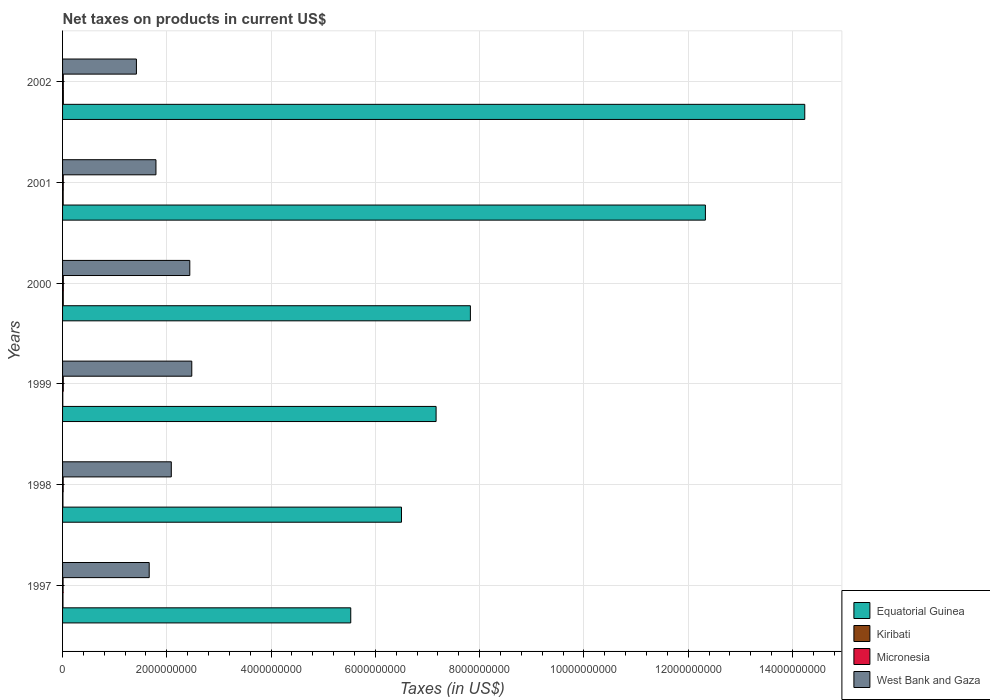How many different coloured bars are there?
Keep it short and to the point. 4. How many groups of bars are there?
Provide a short and direct response. 6. Are the number of bars per tick equal to the number of legend labels?
Your answer should be very brief. Yes. Are the number of bars on each tick of the Y-axis equal?
Give a very brief answer. Yes. How many bars are there on the 5th tick from the top?
Make the answer very short. 4. How many bars are there on the 1st tick from the bottom?
Provide a short and direct response. 4. In how many cases, is the number of bars for a given year not equal to the number of legend labels?
Provide a succinct answer. 0. What is the net taxes on products in Equatorial Guinea in 2000?
Offer a terse response. 7.82e+09. Across all years, what is the maximum net taxes on products in Kiribati?
Your answer should be very brief. 1.52e+07. Across all years, what is the minimum net taxes on products in Kiribati?
Keep it short and to the point. 4.38e+06. What is the total net taxes on products in Kiribati in the graph?
Provide a succinct answer. 6.04e+07. What is the difference between the net taxes on products in Equatorial Guinea in 1999 and that in 2000?
Give a very brief answer. -6.58e+08. What is the difference between the net taxes on products in Kiribati in 2000 and the net taxes on products in Micronesia in 2002?
Offer a very short reply. -7.20e+05. What is the average net taxes on products in Equatorial Guinea per year?
Offer a terse response. 8.93e+09. In the year 1999, what is the difference between the net taxes on products in West Bank and Gaza and net taxes on products in Kiribati?
Provide a short and direct response. 2.47e+09. In how many years, is the net taxes on products in Kiribati greater than 6400000000 US$?
Your response must be concise. 0. What is the ratio of the net taxes on products in Kiribati in 1997 to that in 1999?
Your answer should be very brief. 1.85. What is the difference between the highest and the second highest net taxes on products in Micronesia?
Keep it short and to the point. 4.29e+05. What is the difference between the highest and the lowest net taxes on products in Micronesia?
Provide a short and direct response. 4.64e+06. Is the sum of the net taxes on products in Micronesia in 1998 and 2000 greater than the maximum net taxes on products in West Bank and Gaza across all years?
Offer a terse response. No. Is it the case that in every year, the sum of the net taxes on products in Micronesia and net taxes on products in West Bank and Gaza is greater than the sum of net taxes on products in Equatorial Guinea and net taxes on products in Kiribati?
Make the answer very short. Yes. What does the 4th bar from the top in 1997 represents?
Offer a terse response. Equatorial Guinea. What does the 1st bar from the bottom in 1998 represents?
Provide a succinct answer. Equatorial Guinea. How many bars are there?
Give a very brief answer. 24. Are all the bars in the graph horizontal?
Your response must be concise. Yes. How many years are there in the graph?
Your response must be concise. 6. Does the graph contain any zero values?
Provide a short and direct response. No. How many legend labels are there?
Give a very brief answer. 4. What is the title of the graph?
Offer a very short reply. Net taxes on products in current US$. What is the label or title of the X-axis?
Your answer should be very brief. Taxes (in US$). What is the Taxes (in US$) of Equatorial Guinea in 1997?
Offer a terse response. 5.53e+09. What is the Taxes (in US$) of Kiribati in 1997?
Offer a terse response. 8.11e+06. What is the Taxes (in US$) in Micronesia in 1997?
Provide a short and direct response. 1.00e+07. What is the Taxes (in US$) of West Bank and Gaza in 1997?
Ensure brevity in your answer.  1.66e+09. What is the Taxes (in US$) in Equatorial Guinea in 1998?
Ensure brevity in your answer.  6.50e+09. What is the Taxes (in US$) of Kiribati in 1998?
Your response must be concise. 7.34e+06. What is the Taxes (in US$) in Micronesia in 1998?
Provide a short and direct response. 1.18e+07. What is the Taxes (in US$) in West Bank and Gaza in 1998?
Offer a terse response. 2.09e+09. What is the Taxes (in US$) in Equatorial Guinea in 1999?
Your response must be concise. 7.16e+09. What is the Taxes (in US$) in Kiribati in 1999?
Give a very brief answer. 4.38e+06. What is the Taxes (in US$) of Micronesia in 1999?
Your response must be concise. 1.37e+07. What is the Taxes (in US$) of West Bank and Gaza in 1999?
Your answer should be compact. 2.48e+09. What is the Taxes (in US$) of Equatorial Guinea in 2000?
Ensure brevity in your answer.  7.82e+09. What is the Taxes (in US$) of Kiribati in 2000?
Offer a very short reply. 1.35e+07. What is the Taxes (in US$) in Micronesia in 2000?
Your response must be concise. 1.47e+07. What is the Taxes (in US$) of West Bank and Gaza in 2000?
Provide a succinct answer. 2.44e+09. What is the Taxes (in US$) of Equatorial Guinea in 2001?
Make the answer very short. 1.23e+1. What is the Taxes (in US$) in Kiribati in 2001?
Give a very brief answer. 1.18e+07. What is the Taxes (in US$) of Micronesia in 2001?
Your answer should be compact. 1.35e+07. What is the Taxes (in US$) of West Bank and Gaza in 2001?
Keep it short and to the point. 1.79e+09. What is the Taxes (in US$) of Equatorial Guinea in 2002?
Your answer should be very brief. 1.42e+1. What is the Taxes (in US$) of Kiribati in 2002?
Ensure brevity in your answer.  1.52e+07. What is the Taxes (in US$) of Micronesia in 2002?
Your response must be concise. 1.42e+07. What is the Taxes (in US$) in West Bank and Gaza in 2002?
Provide a succinct answer. 1.42e+09. Across all years, what is the maximum Taxes (in US$) in Equatorial Guinea?
Provide a short and direct response. 1.42e+1. Across all years, what is the maximum Taxes (in US$) in Kiribati?
Make the answer very short. 1.52e+07. Across all years, what is the maximum Taxes (in US$) in Micronesia?
Give a very brief answer. 1.47e+07. Across all years, what is the maximum Taxes (in US$) in West Bank and Gaza?
Your response must be concise. 2.48e+09. Across all years, what is the minimum Taxes (in US$) of Equatorial Guinea?
Keep it short and to the point. 5.53e+09. Across all years, what is the minimum Taxes (in US$) of Kiribati?
Your response must be concise. 4.38e+06. Across all years, what is the minimum Taxes (in US$) in Micronesia?
Offer a terse response. 1.00e+07. Across all years, what is the minimum Taxes (in US$) of West Bank and Gaza?
Make the answer very short. 1.42e+09. What is the total Taxes (in US$) of Equatorial Guinea in the graph?
Your answer should be compact. 5.36e+1. What is the total Taxes (in US$) of Kiribati in the graph?
Offer a very short reply. 6.04e+07. What is the total Taxes (in US$) in Micronesia in the graph?
Your answer should be compact. 7.79e+07. What is the total Taxes (in US$) in West Bank and Gaza in the graph?
Give a very brief answer. 1.19e+1. What is the difference between the Taxes (in US$) in Equatorial Guinea in 1997 and that in 1998?
Your answer should be very brief. -9.73e+08. What is the difference between the Taxes (in US$) of Kiribati in 1997 and that in 1998?
Your response must be concise. 7.73e+05. What is the difference between the Taxes (in US$) in Micronesia in 1997 and that in 1998?
Provide a succinct answer. -1.83e+06. What is the difference between the Taxes (in US$) in West Bank and Gaza in 1997 and that in 1998?
Your answer should be compact. -4.24e+08. What is the difference between the Taxes (in US$) in Equatorial Guinea in 1997 and that in 1999?
Give a very brief answer. -1.64e+09. What is the difference between the Taxes (in US$) of Kiribati in 1997 and that in 1999?
Provide a short and direct response. 3.73e+06. What is the difference between the Taxes (in US$) in Micronesia in 1997 and that in 1999?
Your response must be concise. -3.65e+06. What is the difference between the Taxes (in US$) in West Bank and Gaza in 1997 and that in 1999?
Offer a terse response. -8.17e+08. What is the difference between the Taxes (in US$) in Equatorial Guinea in 1997 and that in 2000?
Make the answer very short. -2.30e+09. What is the difference between the Taxes (in US$) of Kiribati in 1997 and that in 2000?
Offer a very short reply. -5.40e+06. What is the difference between the Taxes (in US$) of Micronesia in 1997 and that in 2000?
Offer a terse response. -4.64e+06. What is the difference between the Taxes (in US$) in West Bank and Gaza in 1997 and that in 2000?
Offer a terse response. -7.79e+08. What is the difference between the Taxes (in US$) of Equatorial Guinea in 1997 and that in 2001?
Give a very brief answer. -6.80e+09. What is the difference between the Taxes (in US$) in Kiribati in 1997 and that in 2001?
Your response must be concise. -3.70e+06. What is the difference between the Taxes (in US$) of Micronesia in 1997 and that in 2001?
Keep it short and to the point. -3.47e+06. What is the difference between the Taxes (in US$) in West Bank and Gaza in 1997 and that in 2001?
Your answer should be compact. -1.29e+08. What is the difference between the Taxes (in US$) of Equatorial Guinea in 1997 and that in 2002?
Ensure brevity in your answer.  -8.71e+09. What is the difference between the Taxes (in US$) of Kiribati in 1997 and that in 2002?
Offer a very short reply. -7.10e+06. What is the difference between the Taxes (in US$) of Micronesia in 1997 and that in 2002?
Give a very brief answer. -4.21e+06. What is the difference between the Taxes (in US$) in West Bank and Gaza in 1997 and that in 2002?
Offer a terse response. 2.45e+08. What is the difference between the Taxes (in US$) in Equatorial Guinea in 1998 and that in 1999?
Your answer should be very brief. -6.64e+08. What is the difference between the Taxes (in US$) of Kiribati in 1998 and that in 1999?
Keep it short and to the point. 2.95e+06. What is the difference between the Taxes (in US$) in Micronesia in 1998 and that in 1999?
Offer a very short reply. -1.82e+06. What is the difference between the Taxes (in US$) in West Bank and Gaza in 1998 and that in 1999?
Offer a terse response. -3.93e+08. What is the difference between the Taxes (in US$) in Equatorial Guinea in 1998 and that in 2000?
Give a very brief answer. -1.32e+09. What is the difference between the Taxes (in US$) of Kiribati in 1998 and that in 2000?
Give a very brief answer. -6.17e+06. What is the difference between the Taxes (in US$) of Micronesia in 1998 and that in 2000?
Offer a terse response. -2.81e+06. What is the difference between the Taxes (in US$) in West Bank and Gaza in 1998 and that in 2000?
Keep it short and to the point. -3.55e+08. What is the difference between the Taxes (in US$) of Equatorial Guinea in 1998 and that in 2001?
Keep it short and to the point. -5.83e+09. What is the difference between the Taxes (in US$) of Kiribati in 1998 and that in 2001?
Your answer should be compact. -4.47e+06. What is the difference between the Taxes (in US$) in Micronesia in 1998 and that in 2001?
Make the answer very short. -1.64e+06. What is the difference between the Taxes (in US$) in West Bank and Gaza in 1998 and that in 2001?
Ensure brevity in your answer.  2.94e+08. What is the difference between the Taxes (in US$) in Equatorial Guinea in 1998 and that in 2002?
Keep it short and to the point. -7.74e+09. What is the difference between the Taxes (in US$) in Kiribati in 1998 and that in 2002?
Offer a terse response. -7.88e+06. What is the difference between the Taxes (in US$) in Micronesia in 1998 and that in 2002?
Give a very brief answer. -2.38e+06. What is the difference between the Taxes (in US$) of West Bank and Gaza in 1998 and that in 2002?
Give a very brief answer. 6.69e+08. What is the difference between the Taxes (in US$) of Equatorial Guinea in 1999 and that in 2000?
Offer a very short reply. -6.58e+08. What is the difference between the Taxes (in US$) in Kiribati in 1999 and that in 2000?
Your answer should be very brief. -9.12e+06. What is the difference between the Taxes (in US$) of Micronesia in 1999 and that in 2000?
Provide a succinct answer. -9.94e+05. What is the difference between the Taxes (in US$) of West Bank and Gaza in 1999 and that in 2000?
Your response must be concise. 3.80e+07. What is the difference between the Taxes (in US$) of Equatorial Guinea in 1999 and that in 2001?
Make the answer very short. -5.17e+09. What is the difference between the Taxes (in US$) of Kiribati in 1999 and that in 2001?
Provide a short and direct response. -7.42e+06. What is the difference between the Taxes (in US$) of Micronesia in 1999 and that in 2001?
Provide a short and direct response. 1.83e+05. What is the difference between the Taxes (in US$) of West Bank and Gaza in 1999 and that in 2001?
Ensure brevity in your answer.  6.87e+08. What is the difference between the Taxes (in US$) of Equatorial Guinea in 1999 and that in 2002?
Make the answer very short. -7.07e+09. What is the difference between the Taxes (in US$) of Kiribati in 1999 and that in 2002?
Ensure brevity in your answer.  -1.08e+07. What is the difference between the Taxes (in US$) in Micronesia in 1999 and that in 2002?
Keep it short and to the point. -5.65e+05. What is the difference between the Taxes (in US$) in West Bank and Gaza in 1999 and that in 2002?
Ensure brevity in your answer.  1.06e+09. What is the difference between the Taxes (in US$) of Equatorial Guinea in 2000 and that in 2001?
Make the answer very short. -4.51e+09. What is the difference between the Taxes (in US$) of Kiribati in 2000 and that in 2001?
Provide a short and direct response. 1.70e+06. What is the difference between the Taxes (in US$) in Micronesia in 2000 and that in 2001?
Make the answer very short. 1.18e+06. What is the difference between the Taxes (in US$) in West Bank and Gaza in 2000 and that in 2001?
Give a very brief answer. 6.49e+08. What is the difference between the Taxes (in US$) in Equatorial Guinea in 2000 and that in 2002?
Make the answer very short. -6.41e+09. What is the difference between the Taxes (in US$) in Kiribati in 2000 and that in 2002?
Provide a succinct answer. -1.70e+06. What is the difference between the Taxes (in US$) of Micronesia in 2000 and that in 2002?
Give a very brief answer. 4.29e+05. What is the difference between the Taxes (in US$) of West Bank and Gaza in 2000 and that in 2002?
Keep it short and to the point. 1.02e+09. What is the difference between the Taxes (in US$) in Equatorial Guinea in 2001 and that in 2002?
Keep it short and to the point. -1.91e+09. What is the difference between the Taxes (in US$) in Kiribati in 2001 and that in 2002?
Provide a succinct answer. -3.41e+06. What is the difference between the Taxes (in US$) of Micronesia in 2001 and that in 2002?
Ensure brevity in your answer.  -7.48e+05. What is the difference between the Taxes (in US$) of West Bank and Gaza in 2001 and that in 2002?
Your answer should be very brief. 3.75e+08. What is the difference between the Taxes (in US$) in Equatorial Guinea in 1997 and the Taxes (in US$) in Kiribati in 1998?
Your answer should be compact. 5.52e+09. What is the difference between the Taxes (in US$) in Equatorial Guinea in 1997 and the Taxes (in US$) in Micronesia in 1998?
Keep it short and to the point. 5.52e+09. What is the difference between the Taxes (in US$) in Equatorial Guinea in 1997 and the Taxes (in US$) in West Bank and Gaza in 1998?
Provide a short and direct response. 3.44e+09. What is the difference between the Taxes (in US$) of Kiribati in 1997 and the Taxes (in US$) of Micronesia in 1998?
Your answer should be compact. -3.73e+06. What is the difference between the Taxes (in US$) of Kiribati in 1997 and the Taxes (in US$) of West Bank and Gaza in 1998?
Give a very brief answer. -2.08e+09. What is the difference between the Taxes (in US$) in Micronesia in 1997 and the Taxes (in US$) in West Bank and Gaza in 1998?
Ensure brevity in your answer.  -2.08e+09. What is the difference between the Taxes (in US$) in Equatorial Guinea in 1997 and the Taxes (in US$) in Kiribati in 1999?
Make the answer very short. 5.52e+09. What is the difference between the Taxes (in US$) in Equatorial Guinea in 1997 and the Taxes (in US$) in Micronesia in 1999?
Make the answer very short. 5.51e+09. What is the difference between the Taxes (in US$) of Equatorial Guinea in 1997 and the Taxes (in US$) of West Bank and Gaza in 1999?
Give a very brief answer. 3.05e+09. What is the difference between the Taxes (in US$) of Kiribati in 1997 and the Taxes (in US$) of Micronesia in 1999?
Offer a very short reply. -5.55e+06. What is the difference between the Taxes (in US$) in Kiribati in 1997 and the Taxes (in US$) in West Bank and Gaza in 1999?
Give a very brief answer. -2.47e+09. What is the difference between the Taxes (in US$) in Micronesia in 1997 and the Taxes (in US$) in West Bank and Gaza in 1999?
Your answer should be very brief. -2.47e+09. What is the difference between the Taxes (in US$) in Equatorial Guinea in 1997 and the Taxes (in US$) in Kiribati in 2000?
Give a very brief answer. 5.51e+09. What is the difference between the Taxes (in US$) in Equatorial Guinea in 1997 and the Taxes (in US$) in Micronesia in 2000?
Your answer should be very brief. 5.51e+09. What is the difference between the Taxes (in US$) of Equatorial Guinea in 1997 and the Taxes (in US$) of West Bank and Gaza in 2000?
Ensure brevity in your answer.  3.09e+09. What is the difference between the Taxes (in US$) of Kiribati in 1997 and the Taxes (in US$) of Micronesia in 2000?
Your response must be concise. -6.55e+06. What is the difference between the Taxes (in US$) in Kiribati in 1997 and the Taxes (in US$) in West Bank and Gaza in 2000?
Provide a short and direct response. -2.43e+09. What is the difference between the Taxes (in US$) of Micronesia in 1997 and the Taxes (in US$) of West Bank and Gaza in 2000?
Your response must be concise. -2.43e+09. What is the difference between the Taxes (in US$) in Equatorial Guinea in 1997 and the Taxes (in US$) in Kiribati in 2001?
Provide a succinct answer. 5.52e+09. What is the difference between the Taxes (in US$) of Equatorial Guinea in 1997 and the Taxes (in US$) of Micronesia in 2001?
Provide a succinct answer. 5.51e+09. What is the difference between the Taxes (in US$) of Equatorial Guinea in 1997 and the Taxes (in US$) of West Bank and Gaza in 2001?
Offer a terse response. 3.74e+09. What is the difference between the Taxes (in US$) in Kiribati in 1997 and the Taxes (in US$) in Micronesia in 2001?
Ensure brevity in your answer.  -5.37e+06. What is the difference between the Taxes (in US$) of Kiribati in 1997 and the Taxes (in US$) of West Bank and Gaza in 2001?
Make the answer very short. -1.78e+09. What is the difference between the Taxes (in US$) of Micronesia in 1997 and the Taxes (in US$) of West Bank and Gaza in 2001?
Ensure brevity in your answer.  -1.78e+09. What is the difference between the Taxes (in US$) in Equatorial Guinea in 1997 and the Taxes (in US$) in Kiribati in 2002?
Ensure brevity in your answer.  5.51e+09. What is the difference between the Taxes (in US$) of Equatorial Guinea in 1997 and the Taxes (in US$) of Micronesia in 2002?
Offer a very short reply. 5.51e+09. What is the difference between the Taxes (in US$) of Equatorial Guinea in 1997 and the Taxes (in US$) of West Bank and Gaza in 2002?
Keep it short and to the point. 4.11e+09. What is the difference between the Taxes (in US$) in Kiribati in 1997 and the Taxes (in US$) in Micronesia in 2002?
Your answer should be compact. -6.12e+06. What is the difference between the Taxes (in US$) of Kiribati in 1997 and the Taxes (in US$) of West Bank and Gaza in 2002?
Ensure brevity in your answer.  -1.41e+09. What is the difference between the Taxes (in US$) of Micronesia in 1997 and the Taxes (in US$) of West Bank and Gaza in 2002?
Offer a very short reply. -1.41e+09. What is the difference between the Taxes (in US$) of Equatorial Guinea in 1998 and the Taxes (in US$) of Kiribati in 1999?
Provide a succinct answer. 6.50e+09. What is the difference between the Taxes (in US$) in Equatorial Guinea in 1998 and the Taxes (in US$) in Micronesia in 1999?
Keep it short and to the point. 6.49e+09. What is the difference between the Taxes (in US$) of Equatorial Guinea in 1998 and the Taxes (in US$) of West Bank and Gaza in 1999?
Offer a terse response. 4.02e+09. What is the difference between the Taxes (in US$) of Kiribati in 1998 and the Taxes (in US$) of Micronesia in 1999?
Offer a very short reply. -6.32e+06. What is the difference between the Taxes (in US$) in Kiribati in 1998 and the Taxes (in US$) in West Bank and Gaza in 1999?
Provide a short and direct response. -2.47e+09. What is the difference between the Taxes (in US$) in Micronesia in 1998 and the Taxes (in US$) in West Bank and Gaza in 1999?
Make the answer very short. -2.47e+09. What is the difference between the Taxes (in US$) in Equatorial Guinea in 1998 and the Taxes (in US$) in Kiribati in 2000?
Your answer should be compact. 6.49e+09. What is the difference between the Taxes (in US$) of Equatorial Guinea in 1998 and the Taxes (in US$) of Micronesia in 2000?
Make the answer very short. 6.49e+09. What is the difference between the Taxes (in US$) of Equatorial Guinea in 1998 and the Taxes (in US$) of West Bank and Gaza in 2000?
Ensure brevity in your answer.  4.06e+09. What is the difference between the Taxes (in US$) of Kiribati in 1998 and the Taxes (in US$) of Micronesia in 2000?
Ensure brevity in your answer.  -7.32e+06. What is the difference between the Taxes (in US$) of Kiribati in 1998 and the Taxes (in US$) of West Bank and Gaza in 2000?
Provide a succinct answer. -2.43e+09. What is the difference between the Taxes (in US$) in Micronesia in 1998 and the Taxes (in US$) in West Bank and Gaza in 2000?
Give a very brief answer. -2.43e+09. What is the difference between the Taxes (in US$) of Equatorial Guinea in 1998 and the Taxes (in US$) of Kiribati in 2001?
Your answer should be compact. 6.49e+09. What is the difference between the Taxes (in US$) in Equatorial Guinea in 1998 and the Taxes (in US$) in Micronesia in 2001?
Offer a terse response. 6.49e+09. What is the difference between the Taxes (in US$) in Equatorial Guinea in 1998 and the Taxes (in US$) in West Bank and Gaza in 2001?
Give a very brief answer. 4.71e+09. What is the difference between the Taxes (in US$) of Kiribati in 1998 and the Taxes (in US$) of Micronesia in 2001?
Provide a short and direct response. -6.14e+06. What is the difference between the Taxes (in US$) of Kiribati in 1998 and the Taxes (in US$) of West Bank and Gaza in 2001?
Keep it short and to the point. -1.78e+09. What is the difference between the Taxes (in US$) in Micronesia in 1998 and the Taxes (in US$) in West Bank and Gaza in 2001?
Your response must be concise. -1.78e+09. What is the difference between the Taxes (in US$) of Equatorial Guinea in 1998 and the Taxes (in US$) of Kiribati in 2002?
Keep it short and to the point. 6.49e+09. What is the difference between the Taxes (in US$) of Equatorial Guinea in 1998 and the Taxes (in US$) of Micronesia in 2002?
Ensure brevity in your answer.  6.49e+09. What is the difference between the Taxes (in US$) in Equatorial Guinea in 1998 and the Taxes (in US$) in West Bank and Gaza in 2002?
Your response must be concise. 5.08e+09. What is the difference between the Taxes (in US$) in Kiribati in 1998 and the Taxes (in US$) in Micronesia in 2002?
Provide a short and direct response. -6.89e+06. What is the difference between the Taxes (in US$) in Kiribati in 1998 and the Taxes (in US$) in West Bank and Gaza in 2002?
Make the answer very short. -1.41e+09. What is the difference between the Taxes (in US$) in Micronesia in 1998 and the Taxes (in US$) in West Bank and Gaza in 2002?
Ensure brevity in your answer.  -1.40e+09. What is the difference between the Taxes (in US$) in Equatorial Guinea in 1999 and the Taxes (in US$) in Kiribati in 2000?
Your answer should be very brief. 7.15e+09. What is the difference between the Taxes (in US$) of Equatorial Guinea in 1999 and the Taxes (in US$) of Micronesia in 2000?
Provide a short and direct response. 7.15e+09. What is the difference between the Taxes (in US$) in Equatorial Guinea in 1999 and the Taxes (in US$) in West Bank and Gaza in 2000?
Provide a succinct answer. 4.72e+09. What is the difference between the Taxes (in US$) in Kiribati in 1999 and the Taxes (in US$) in Micronesia in 2000?
Give a very brief answer. -1.03e+07. What is the difference between the Taxes (in US$) in Kiribati in 1999 and the Taxes (in US$) in West Bank and Gaza in 2000?
Keep it short and to the point. -2.44e+09. What is the difference between the Taxes (in US$) in Micronesia in 1999 and the Taxes (in US$) in West Bank and Gaza in 2000?
Ensure brevity in your answer.  -2.43e+09. What is the difference between the Taxes (in US$) in Equatorial Guinea in 1999 and the Taxes (in US$) in Kiribati in 2001?
Offer a very short reply. 7.15e+09. What is the difference between the Taxes (in US$) in Equatorial Guinea in 1999 and the Taxes (in US$) in Micronesia in 2001?
Give a very brief answer. 7.15e+09. What is the difference between the Taxes (in US$) in Equatorial Guinea in 1999 and the Taxes (in US$) in West Bank and Gaza in 2001?
Make the answer very short. 5.37e+09. What is the difference between the Taxes (in US$) of Kiribati in 1999 and the Taxes (in US$) of Micronesia in 2001?
Provide a short and direct response. -9.10e+06. What is the difference between the Taxes (in US$) of Kiribati in 1999 and the Taxes (in US$) of West Bank and Gaza in 2001?
Your answer should be compact. -1.79e+09. What is the difference between the Taxes (in US$) in Micronesia in 1999 and the Taxes (in US$) in West Bank and Gaza in 2001?
Provide a short and direct response. -1.78e+09. What is the difference between the Taxes (in US$) in Equatorial Guinea in 1999 and the Taxes (in US$) in Kiribati in 2002?
Offer a terse response. 7.15e+09. What is the difference between the Taxes (in US$) in Equatorial Guinea in 1999 and the Taxes (in US$) in Micronesia in 2002?
Offer a very short reply. 7.15e+09. What is the difference between the Taxes (in US$) in Equatorial Guinea in 1999 and the Taxes (in US$) in West Bank and Gaza in 2002?
Offer a terse response. 5.75e+09. What is the difference between the Taxes (in US$) of Kiribati in 1999 and the Taxes (in US$) of Micronesia in 2002?
Provide a succinct answer. -9.84e+06. What is the difference between the Taxes (in US$) of Kiribati in 1999 and the Taxes (in US$) of West Bank and Gaza in 2002?
Your response must be concise. -1.41e+09. What is the difference between the Taxes (in US$) of Micronesia in 1999 and the Taxes (in US$) of West Bank and Gaza in 2002?
Keep it short and to the point. -1.40e+09. What is the difference between the Taxes (in US$) of Equatorial Guinea in 2000 and the Taxes (in US$) of Kiribati in 2001?
Your answer should be compact. 7.81e+09. What is the difference between the Taxes (in US$) of Equatorial Guinea in 2000 and the Taxes (in US$) of Micronesia in 2001?
Provide a succinct answer. 7.81e+09. What is the difference between the Taxes (in US$) in Equatorial Guinea in 2000 and the Taxes (in US$) in West Bank and Gaza in 2001?
Provide a succinct answer. 6.03e+09. What is the difference between the Taxes (in US$) in Kiribati in 2000 and the Taxes (in US$) in Micronesia in 2001?
Give a very brief answer. 2.85e+04. What is the difference between the Taxes (in US$) in Kiribati in 2000 and the Taxes (in US$) in West Bank and Gaza in 2001?
Your answer should be very brief. -1.78e+09. What is the difference between the Taxes (in US$) in Micronesia in 2000 and the Taxes (in US$) in West Bank and Gaza in 2001?
Ensure brevity in your answer.  -1.78e+09. What is the difference between the Taxes (in US$) of Equatorial Guinea in 2000 and the Taxes (in US$) of Kiribati in 2002?
Keep it short and to the point. 7.81e+09. What is the difference between the Taxes (in US$) in Equatorial Guinea in 2000 and the Taxes (in US$) in Micronesia in 2002?
Your answer should be very brief. 7.81e+09. What is the difference between the Taxes (in US$) in Equatorial Guinea in 2000 and the Taxes (in US$) in West Bank and Gaza in 2002?
Give a very brief answer. 6.41e+09. What is the difference between the Taxes (in US$) in Kiribati in 2000 and the Taxes (in US$) in Micronesia in 2002?
Offer a terse response. -7.20e+05. What is the difference between the Taxes (in US$) of Kiribati in 2000 and the Taxes (in US$) of West Bank and Gaza in 2002?
Ensure brevity in your answer.  -1.40e+09. What is the difference between the Taxes (in US$) in Micronesia in 2000 and the Taxes (in US$) in West Bank and Gaza in 2002?
Give a very brief answer. -1.40e+09. What is the difference between the Taxes (in US$) in Equatorial Guinea in 2001 and the Taxes (in US$) in Kiribati in 2002?
Your answer should be compact. 1.23e+1. What is the difference between the Taxes (in US$) in Equatorial Guinea in 2001 and the Taxes (in US$) in Micronesia in 2002?
Your answer should be compact. 1.23e+1. What is the difference between the Taxes (in US$) in Equatorial Guinea in 2001 and the Taxes (in US$) in West Bank and Gaza in 2002?
Your response must be concise. 1.09e+1. What is the difference between the Taxes (in US$) in Kiribati in 2001 and the Taxes (in US$) in Micronesia in 2002?
Your answer should be very brief. -2.42e+06. What is the difference between the Taxes (in US$) of Kiribati in 2001 and the Taxes (in US$) of West Bank and Gaza in 2002?
Provide a short and direct response. -1.40e+09. What is the difference between the Taxes (in US$) of Micronesia in 2001 and the Taxes (in US$) of West Bank and Gaza in 2002?
Offer a terse response. -1.40e+09. What is the average Taxes (in US$) of Equatorial Guinea per year?
Your answer should be compact. 8.93e+09. What is the average Taxes (in US$) in Kiribati per year?
Offer a very short reply. 1.01e+07. What is the average Taxes (in US$) in Micronesia per year?
Keep it short and to the point. 1.30e+07. What is the average Taxes (in US$) of West Bank and Gaza per year?
Your answer should be very brief. 1.98e+09. In the year 1997, what is the difference between the Taxes (in US$) in Equatorial Guinea and Taxes (in US$) in Kiribati?
Keep it short and to the point. 5.52e+09. In the year 1997, what is the difference between the Taxes (in US$) of Equatorial Guinea and Taxes (in US$) of Micronesia?
Provide a succinct answer. 5.52e+09. In the year 1997, what is the difference between the Taxes (in US$) of Equatorial Guinea and Taxes (in US$) of West Bank and Gaza?
Make the answer very short. 3.87e+09. In the year 1997, what is the difference between the Taxes (in US$) in Kiribati and Taxes (in US$) in Micronesia?
Keep it short and to the point. -1.90e+06. In the year 1997, what is the difference between the Taxes (in US$) in Kiribati and Taxes (in US$) in West Bank and Gaza?
Offer a terse response. -1.65e+09. In the year 1997, what is the difference between the Taxes (in US$) of Micronesia and Taxes (in US$) of West Bank and Gaza?
Ensure brevity in your answer.  -1.65e+09. In the year 1998, what is the difference between the Taxes (in US$) of Equatorial Guinea and Taxes (in US$) of Kiribati?
Keep it short and to the point. 6.49e+09. In the year 1998, what is the difference between the Taxes (in US$) of Equatorial Guinea and Taxes (in US$) of Micronesia?
Provide a short and direct response. 6.49e+09. In the year 1998, what is the difference between the Taxes (in US$) in Equatorial Guinea and Taxes (in US$) in West Bank and Gaza?
Offer a very short reply. 4.42e+09. In the year 1998, what is the difference between the Taxes (in US$) in Kiribati and Taxes (in US$) in Micronesia?
Your answer should be compact. -4.51e+06. In the year 1998, what is the difference between the Taxes (in US$) in Kiribati and Taxes (in US$) in West Bank and Gaza?
Your answer should be very brief. -2.08e+09. In the year 1998, what is the difference between the Taxes (in US$) in Micronesia and Taxes (in US$) in West Bank and Gaza?
Give a very brief answer. -2.07e+09. In the year 1999, what is the difference between the Taxes (in US$) of Equatorial Guinea and Taxes (in US$) of Kiribati?
Your response must be concise. 7.16e+09. In the year 1999, what is the difference between the Taxes (in US$) of Equatorial Guinea and Taxes (in US$) of Micronesia?
Offer a terse response. 7.15e+09. In the year 1999, what is the difference between the Taxes (in US$) of Equatorial Guinea and Taxes (in US$) of West Bank and Gaza?
Your answer should be very brief. 4.69e+09. In the year 1999, what is the difference between the Taxes (in US$) of Kiribati and Taxes (in US$) of Micronesia?
Provide a succinct answer. -9.28e+06. In the year 1999, what is the difference between the Taxes (in US$) of Kiribati and Taxes (in US$) of West Bank and Gaza?
Your response must be concise. -2.47e+09. In the year 1999, what is the difference between the Taxes (in US$) in Micronesia and Taxes (in US$) in West Bank and Gaza?
Your answer should be compact. -2.46e+09. In the year 2000, what is the difference between the Taxes (in US$) in Equatorial Guinea and Taxes (in US$) in Kiribati?
Offer a terse response. 7.81e+09. In the year 2000, what is the difference between the Taxes (in US$) in Equatorial Guinea and Taxes (in US$) in Micronesia?
Ensure brevity in your answer.  7.81e+09. In the year 2000, what is the difference between the Taxes (in US$) of Equatorial Guinea and Taxes (in US$) of West Bank and Gaza?
Keep it short and to the point. 5.38e+09. In the year 2000, what is the difference between the Taxes (in US$) in Kiribati and Taxes (in US$) in Micronesia?
Give a very brief answer. -1.15e+06. In the year 2000, what is the difference between the Taxes (in US$) in Kiribati and Taxes (in US$) in West Bank and Gaza?
Make the answer very short. -2.43e+09. In the year 2000, what is the difference between the Taxes (in US$) in Micronesia and Taxes (in US$) in West Bank and Gaza?
Offer a very short reply. -2.43e+09. In the year 2001, what is the difference between the Taxes (in US$) in Equatorial Guinea and Taxes (in US$) in Kiribati?
Offer a very short reply. 1.23e+1. In the year 2001, what is the difference between the Taxes (in US$) in Equatorial Guinea and Taxes (in US$) in Micronesia?
Offer a very short reply. 1.23e+1. In the year 2001, what is the difference between the Taxes (in US$) in Equatorial Guinea and Taxes (in US$) in West Bank and Gaza?
Ensure brevity in your answer.  1.05e+1. In the year 2001, what is the difference between the Taxes (in US$) in Kiribati and Taxes (in US$) in Micronesia?
Your answer should be very brief. -1.67e+06. In the year 2001, what is the difference between the Taxes (in US$) in Kiribati and Taxes (in US$) in West Bank and Gaza?
Offer a very short reply. -1.78e+09. In the year 2001, what is the difference between the Taxes (in US$) of Micronesia and Taxes (in US$) of West Bank and Gaza?
Offer a very short reply. -1.78e+09. In the year 2002, what is the difference between the Taxes (in US$) in Equatorial Guinea and Taxes (in US$) in Kiribati?
Offer a terse response. 1.42e+1. In the year 2002, what is the difference between the Taxes (in US$) in Equatorial Guinea and Taxes (in US$) in Micronesia?
Offer a terse response. 1.42e+1. In the year 2002, what is the difference between the Taxes (in US$) of Equatorial Guinea and Taxes (in US$) of West Bank and Gaza?
Your answer should be compact. 1.28e+1. In the year 2002, what is the difference between the Taxes (in US$) in Kiribati and Taxes (in US$) in Micronesia?
Your answer should be compact. 9.85e+05. In the year 2002, what is the difference between the Taxes (in US$) in Kiribati and Taxes (in US$) in West Bank and Gaza?
Offer a very short reply. -1.40e+09. In the year 2002, what is the difference between the Taxes (in US$) in Micronesia and Taxes (in US$) in West Bank and Gaza?
Ensure brevity in your answer.  -1.40e+09. What is the ratio of the Taxes (in US$) in Equatorial Guinea in 1997 to that in 1998?
Make the answer very short. 0.85. What is the ratio of the Taxes (in US$) in Kiribati in 1997 to that in 1998?
Your answer should be very brief. 1.11. What is the ratio of the Taxes (in US$) in Micronesia in 1997 to that in 1998?
Keep it short and to the point. 0.85. What is the ratio of the Taxes (in US$) in West Bank and Gaza in 1997 to that in 1998?
Make the answer very short. 0.8. What is the ratio of the Taxes (in US$) in Equatorial Guinea in 1997 to that in 1999?
Keep it short and to the point. 0.77. What is the ratio of the Taxes (in US$) of Kiribati in 1997 to that in 1999?
Your answer should be compact. 1.85. What is the ratio of the Taxes (in US$) in Micronesia in 1997 to that in 1999?
Make the answer very short. 0.73. What is the ratio of the Taxes (in US$) in West Bank and Gaza in 1997 to that in 1999?
Your answer should be very brief. 0.67. What is the ratio of the Taxes (in US$) in Equatorial Guinea in 1997 to that in 2000?
Give a very brief answer. 0.71. What is the ratio of the Taxes (in US$) in Kiribati in 1997 to that in 2000?
Give a very brief answer. 0.6. What is the ratio of the Taxes (in US$) in Micronesia in 1997 to that in 2000?
Your answer should be compact. 0.68. What is the ratio of the Taxes (in US$) in West Bank and Gaza in 1997 to that in 2000?
Make the answer very short. 0.68. What is the ratio of the Taxes (in US$) of Equatorial Guinea in 1997 to that in 2001?
Your answer should be compact. 0.45. What is the ratio of the Taxes (in US$) of Kiribati in 1997 to that in 2001?
Provide a short and direct response. 0.69. What is the ratio of the Taxes (in US$) of Micronesia in 1997 to that in 2001?
Offer a very short reply. 0.74. What is the ratio of the Taxes (in US$) in West Bank and Gaza in 1997 to that in 2001?
Provide a short and direct response. 0.93. What is the ratio of the Taxes (in US$) of Equatorial Guinea in 1997 to that in 2002?
Your response must be concise. 0.39. What is the ratio of the Taxes (in US$) of Kiribati in 1997 to that in 2002?
Provide a succinct answer. 0.53. What is the ratio of the Taxes (in US$) of Micronesia in 1997 to that in 2002?
Make the answer very short. 0.7. What is the ratio of the Taxes (in US$) in West Bank and Gaza in 1997 to that in 2002?
Keep it short and to the point. 1.17. What is the ratio of the Taxes (in US$) in Equatorial Guinea in 1998 to that in 1999?
Your answer should be compact. 0.91. What is the ratio of the Taxes (in US$) in Kiribati in 1998 to that in 1999?
Offer a very short reply. 1.67. What is the ratio of the Taxes (in US$) of Micronesia in 1998 to that in 1999?
Provide a short and direct response. 0.87. What is the ratio of the Taxes (in US$) of West Bank and Gaza in 1998 to that in 1999?
Your answer should be compact. 0.84. What is the ratio of the Taxes (in US$) in Equatorial Guinea in 1998 to that in 2000?
Keep it short and to the point. 0.83. What is the ratio of the Taxes (in US$) in Kiribati in 1998 to that in 2000?
Provide a succinct answer. 0.54. What is the ratio of the Taxes (in US$) of Micronesia in 1998 to that in 2000?
Provide a short and direct response. 0.81. What is the ratio of the Taxes (in US$) of West Bank and Gaza in 1998 to that in 2000?
Keep it short and to the point. 0.85. What is the ratio of the Taxes (in US$) of Equatorial Guinea in 1998 to that in 2001?
Give a very brief answer. 0.53. What is the ratio of the Taxes (in US$) of Kiribati in 1998 to that in 2001?
Your response must be concise. 0.62. What is the ratio of the Taxes (in US$) in Micronesia in 1998 to that in 2001?
Your response must be concise. 0.88. What is the ratio of the Taxes (in US$) of West Bank and Gaza in 1998 to that in 2001?
Give a very brief answer. 1.16. What is the ratio of the Taxes (in US$) of Equatorial Guinea in 1998 to that in 2002?
Make the answer very short. 0.46. What is the ratio of the Taxes (in US$) in Kiribati in 1998 to that in 2002?
Offer a very short reply. 0.48. What is the ratio of the Taxes (in US$) in Micronesia in 1998 to that in 2002?
Offer a terse response. 0.83. What is the ratio of the Taxes (in US$) of West Bank and Gaza in 1998 to that in 2002?
Ensure brevity in your answer.  1.47. What is the ratio of the Taxes (in US$) of Equatorial Guinea in 1999 to that in 2000?
Offer a terse response. 0.92. What is the ratio of the Taxes (in US$) in Kiribati in 1999 to that in 2000?
Offer a very short reply. 0.32. What is the ratio of the Taxes (in US$) of Micronesia in 1999 to that in 2000?
Provide a short and direct response. 0.93. What is the ratio of the Taxes (in US$) of West Bank and Gaza in 1999 to that in 2000?
Your response must be concise. 1.02. What is the ratio of the Taxes (in US$) in Equatorial Guinea in 1999 to that in 2001?
Offer a very short reply. 0.58. What is the ratio of the Taxes (in US$) in Kiribati in 1999 to that in 2001?
Your response must be concise. 0.37. What is the ratio of the Taxes (in US$) in Micronesia in 1999 to that in 2001?
Your answer should be very brief. 1.01. What is the ratio of the Taxes (in US$) in West Bank and Gaza in 1999 to that in 2001?
Give a very brief answer. 1.38. What is the ratio of the Taxes (in US$) of Equatorial Guinea in 1999 to that in 2002?
Keep it short and to the point. 0.5. What is the ratio of the Taxes (in US$) in Kiribati in 1999 to that in 2002?
Provide a succinct answer. 0.29. What is the ratio of the Taxes (in US$) in Micronesia in 1999 to that in 2002?
Offer a very short reply. 0.96. What is the ratio of the Taxes (in US$) of West Bank and Gaza in 1999 to that in 2002?
Keep it short and to the point. 1.75. What is the ratio of the Taxes (in US$) of Equatorial Guinea in 2000 to that in 2001?
Give a very brief answer. 0.63. What is the ratio of the Taxes (in US$) in Kiribati in 2000 to that in 2001?
Offer a terse response. 1.14. What is the ratio of the Taxes (in US$) in Micronesia in 2000 to that in 2001?
Offer a very short reply. 1.09. What is the ratio of the Taxes (in US$) in West Bank and Gaza in 2000 to that in 2001?
Your answer should be very brief. 1.36. What is the ratio of the Taxes (in US$) in Equatorial Guinea in 2000 to that in 2002?
Keep it short and to the point. 0.55. What is the ratio of the Taxes (in US$) in Kiribati in 2000 to that in 2002?
Provide a short and direct response. 0.89. What is the ratio of the Taxes (in US$) of Micronesia in 2000 to that in 2002?
Your answer should be very brief. 1.03. What is the ratio of the Taxes (in US$) of West Bank and Gaza in 2000 to that in 2002?
Offer a very short reply. 1.72. What is the ratio of the Taxes (in US$) in Equatorial Guinea in 2001 to that in 2002?
Your answer should be very brief. 0.87. What is the ratio of the Taxes (in US$) of Kiribati in 2001 to that in 2002?
Your answer should be very brief. 0.78. What is the ratio of the Taxes (in US$) of Micronesia in 2001 to that in 2002?
Make the answer very short. 0.95. What is the ratio of the Taxes (in US$) of West Bank and Gaza in 2001 to that in 2002?
Offer a very short reply. 1.26. What is the difference between the highest and the second highest Taxes (in US$) in Equatorial Guinea?
Provide a succinct answer. 1.91e+09. What is the difference between the highest and the second highest Taxes (in US$) of Kiribati?
Ensure brevity in your answer.  1.70e+06. What is the difference between the highest and the second highest Taxes (in US$) in Micronesia?
Provide a succinct answer. 4.29e+05. What is the difference between the highest and the second highest Taxes (in US$) in West Bank and Gaza?
Keep it short and to the point. 3.80e+07. What is the difference between the highest and the lowest Taxes (in US$) of Equatorial Guinea?
Offer a terse response. 8.71e+09. What is the difference between the highest and the lowest Taxes (in US$) of Kiribati?
Ensure brevity in your answer.  1.08e+07. What is the difference between the highest and the lowest Taxes (in US$) in Micronesia?
Give a very brief answer. 4.64e+06. What is the difference between the highest and the lowest Taxes (in US$) in West Bank and Gaza?
Ensure brevity in your answer.  1.06e+09. 